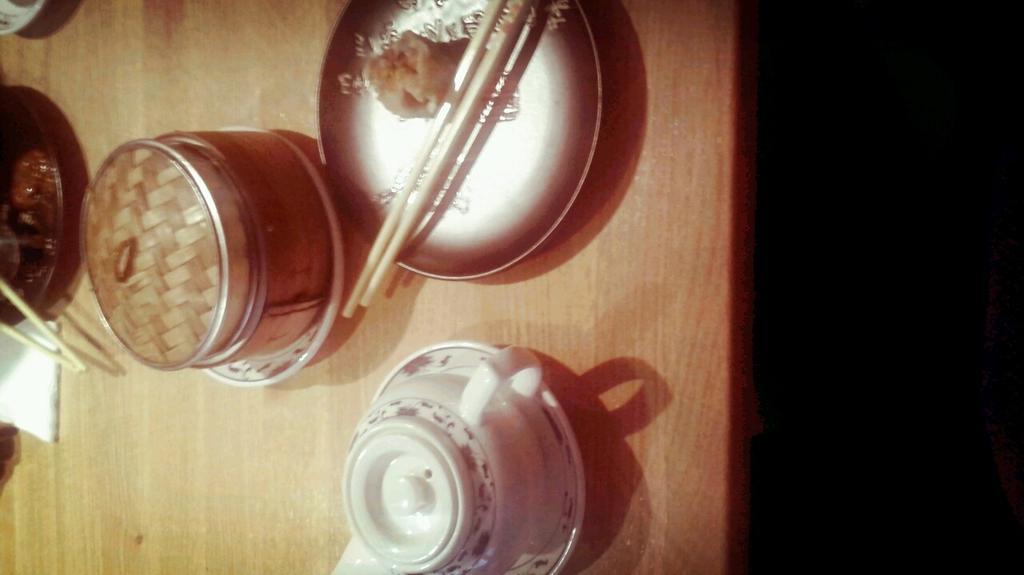In one or two sentences, can you explain what this image depicts? In this image we can see a table on which few things are placed like a jar, a plate with food items and chop sticks and cup with a saucer. 